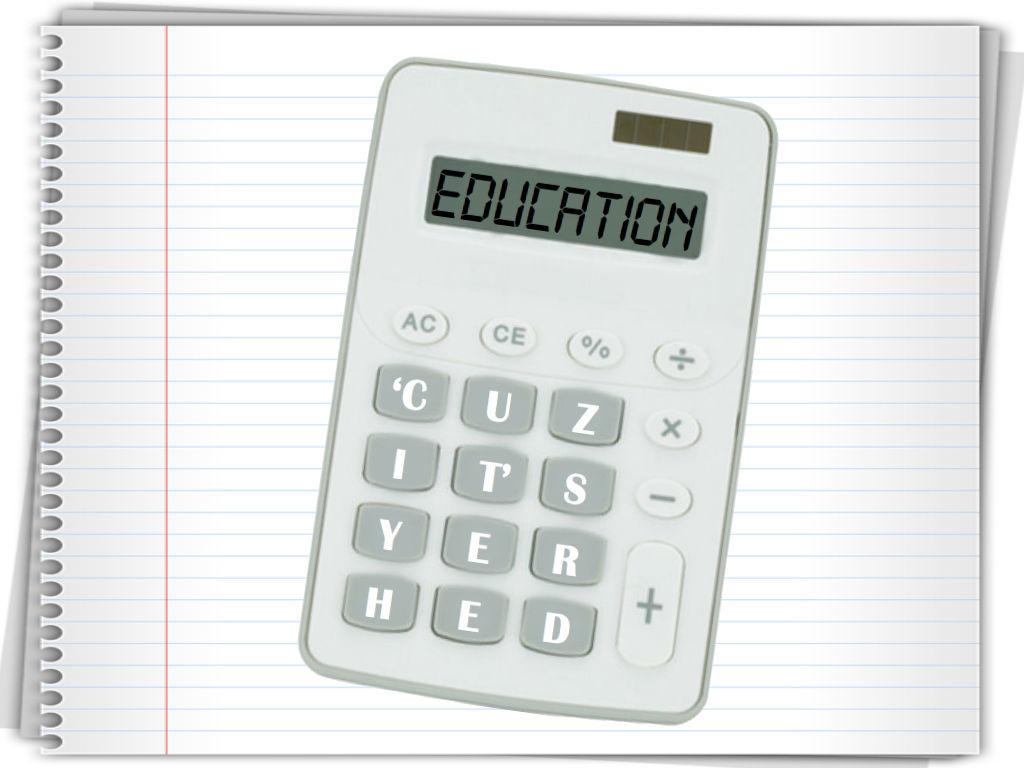<image>
Provide a brief description of the given image. A calculator showing the word education is sitting on a notebook. 